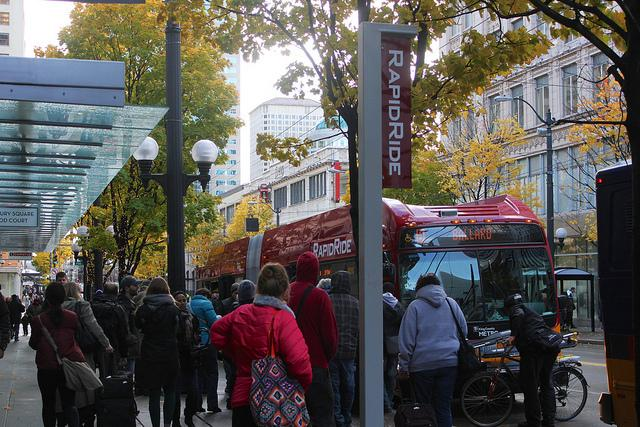Who are the people gathering there? tourists 